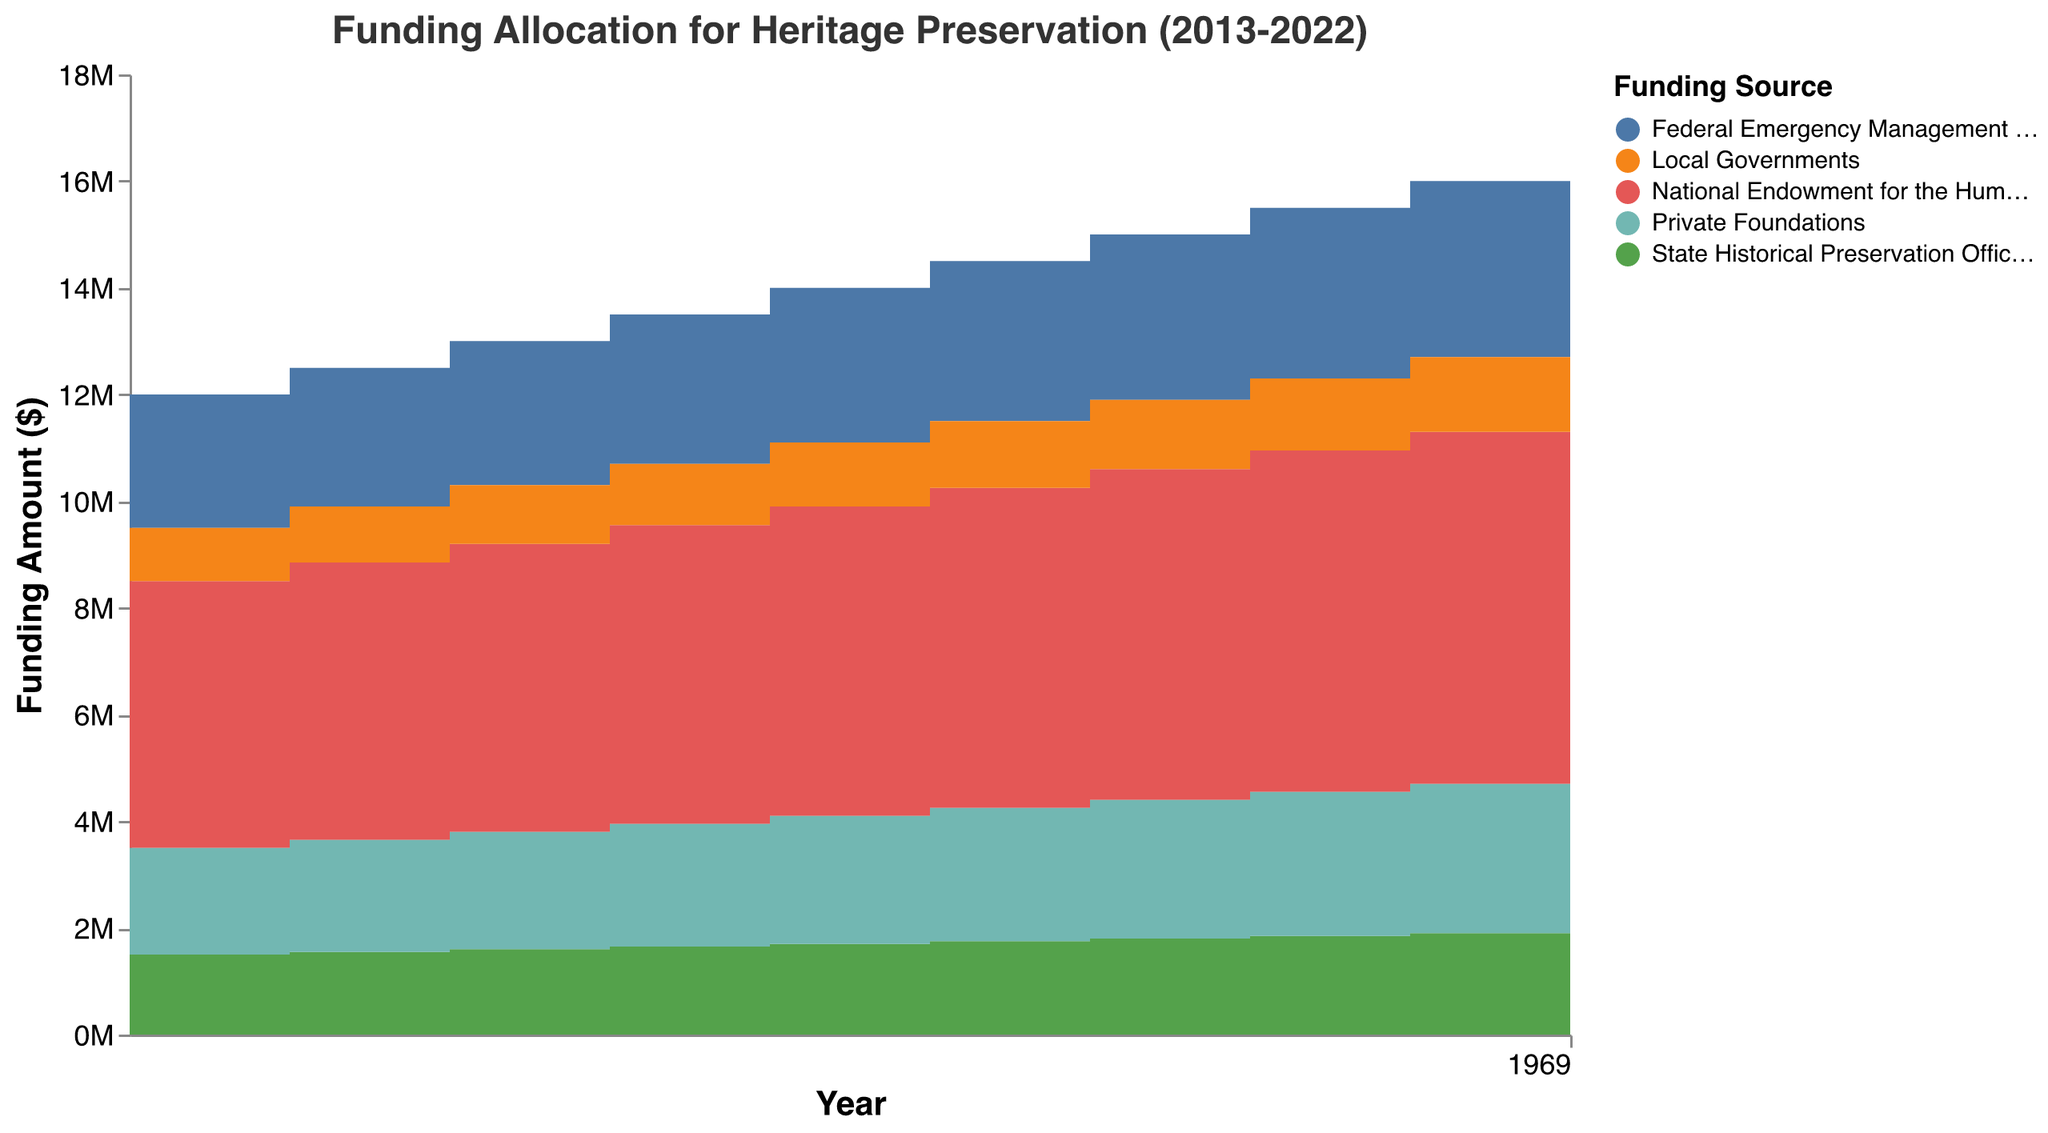What is the title of the chart? The title is displayed at the top of the chart, clearly stating the subject of the visualization.
Answer: Funding Allocation for Heritage Preservation (2013-2022) Which funding source allocated the most funds in 2022? By observing the layers in the step area chart for 2022, the highest layer corresponds to the National Endowment for the Humanities, indicating it allocated the most funds.
Answer: National Endowment for the Humanities How much funding did Local Governments allocate in 2017? To find this, locate the year 2017 on the x-axis and then check the corresponding value for Local Governments from the chart's color legend.
Answer: $1,200,000 By how much did the funding from Private Foundations increase from 2013 to 2022? Find the funding amounts for Private Foundations in 2013 and 2022 ($2,000,000 and $2,900,000, respectively). Subtract the earlier amount from the later amount: $2,900,000 - $2,000,000 = $900,000.
Answer: $900,000 Which funding source showed a consistent increase every year from 2013 to 2022? Evaluate the step line for each funding source over the given years. The National Endowment for the Humanities shows a smooth and consistent upward trend year over year.
Answer: National Endowment for the Humanities How does the total funding in 2018 compare to the total funding in 2020? Stack all funding amounts for 2018 and 2020, respectively, and compare: 2018 total is $6,000,000 + $3,000,000 + $1,750,000 + $1,250,000 + $2,500,000 = $14,500,000, and 2020 total is $6,400,000 + $3,200,000 + $1,850,000 + $1,350,000 + $2,700,000 = $15,500,000.
Answer: 2020 > 2018 Which funding source had the smallest allocation increase from 2013 to 2022? Calculate the difference for each funding source between 2013 and 2022 and find the smallest: Local Governments increased from $1,000,000 (2013) to $1,450,000 (2022), resulting in the smallest increase of $450,000.
Answer: Local Governments What is the total amount of funding allocated by all sources in 2019? Sum the values for all funding sources in the year 2019: $6,200,000 + $3,100,000 + $1,800,000 + $1,300,000 + $2,600,000 = $15,000,000.
Answer: $15,000,000 By what percentage did the funding from State Historical Preservation Offices increase from 2013 to 2015? Determine the difference between 2013 and 2015 for State Historical Preservation Offices: $1,600,000 - $1,500,000 = $100,000. Divide the increase by the 2013 amount and multiply by 100: ($100,000 / $1,500,000) × 100 ≈ 6.67%.
Answer: 6.67% How does the slope of the funding line for Federal Emergency Management Agency change over the decade? Observing the step transitions for FEMA across the years from 2013 to 2022 shows a steady and linear increase in funding each year without drastic changes.
Answer: Steady and linear 